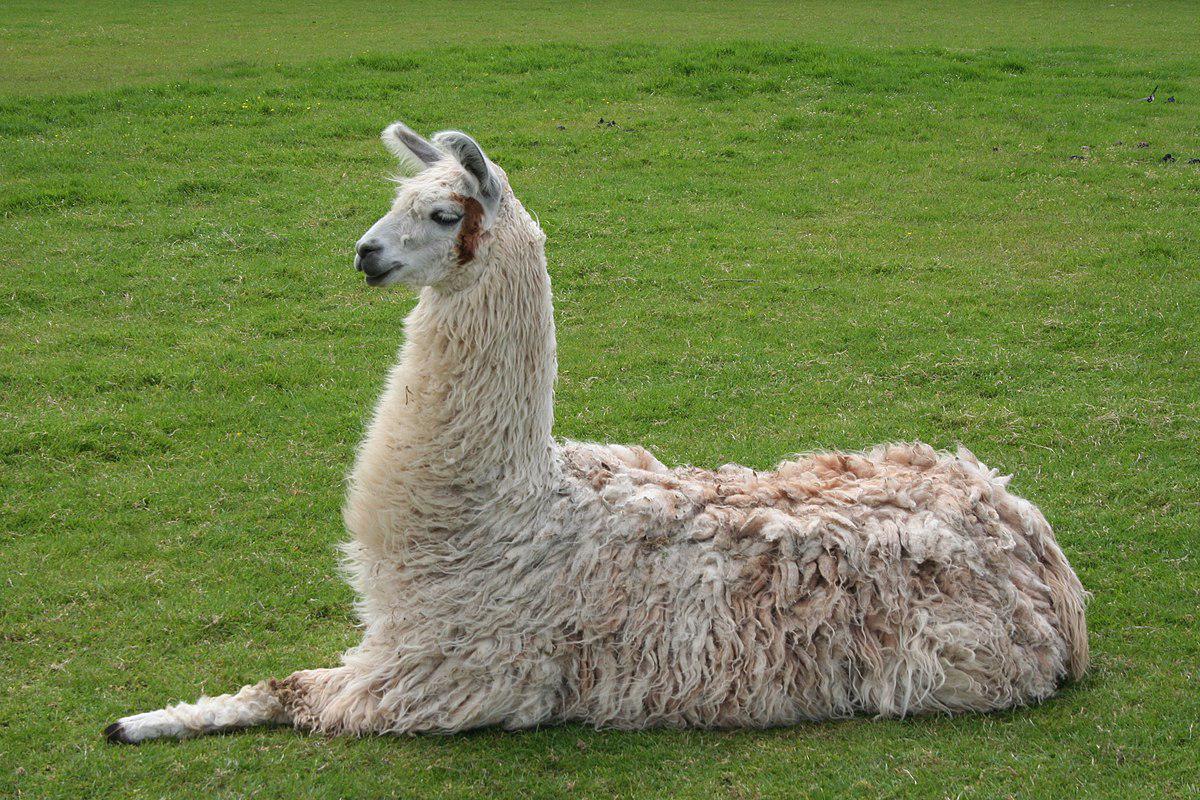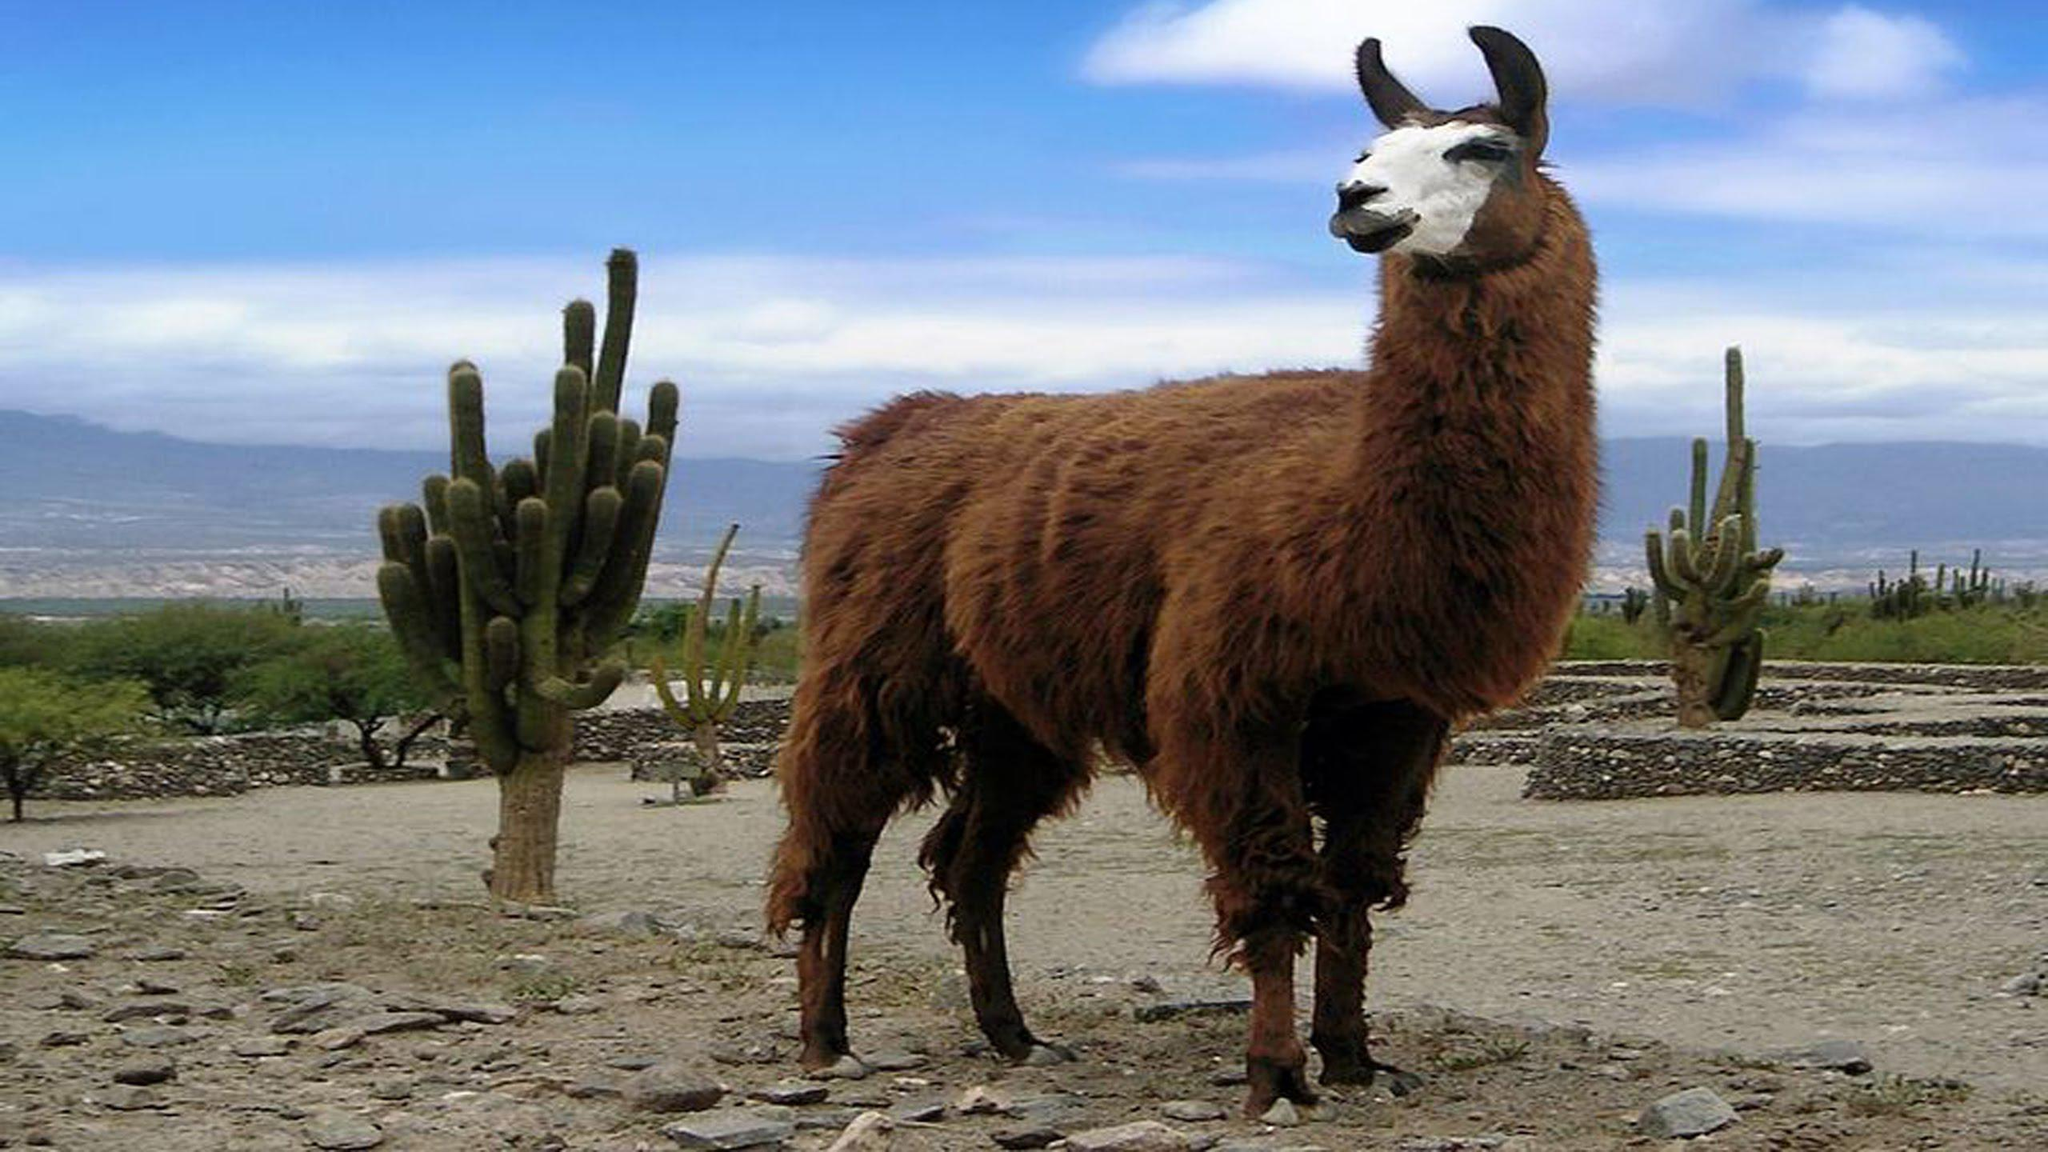The first image is the image on the left, the second image is the image on the right. Evaluate the accuracy of this statement regarding the images: "There are exactly two llamas.". Is it true? Answer yes or no. Yes. 